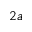Convert formula to latex. <formula><loc_0><loc_0><loc_500><loc_500>2 a</formula> 